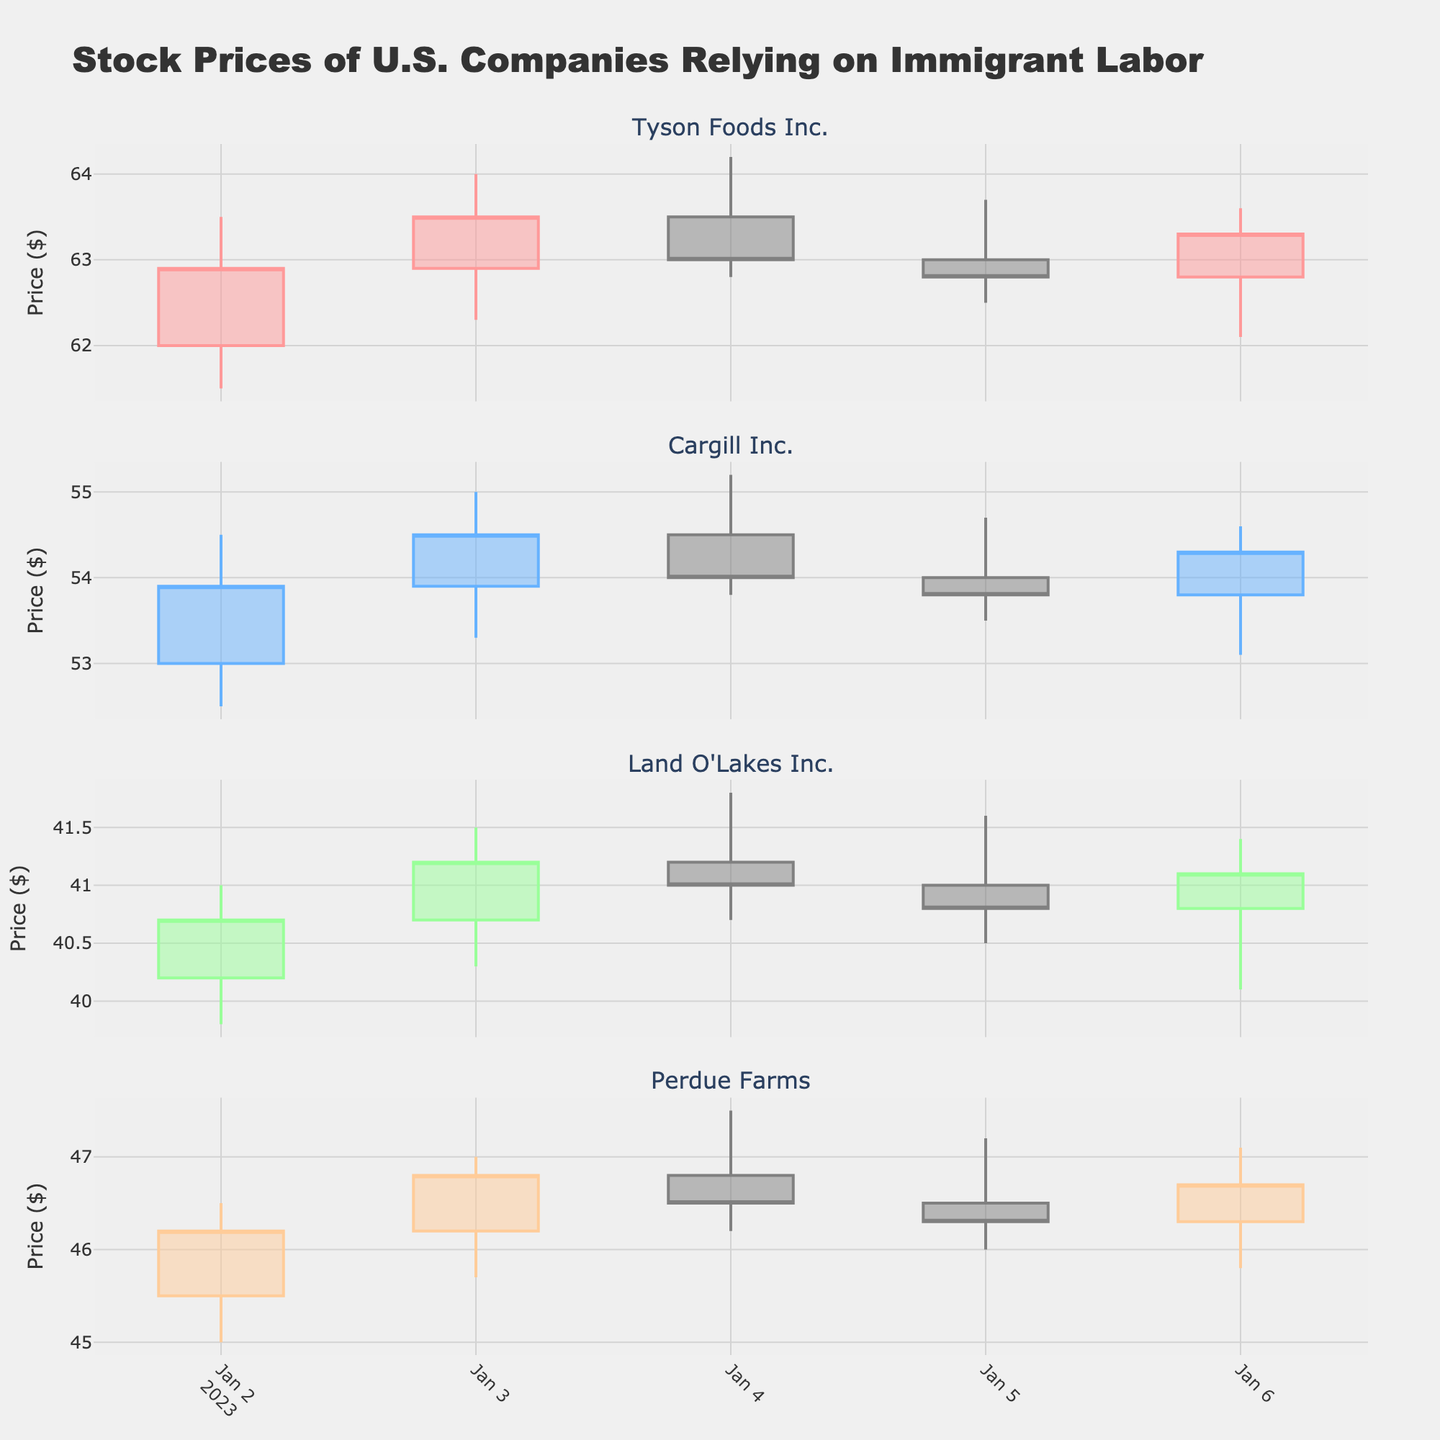What is the title of the figure? The title is usually located at the top of the figure in a larger and bolder font. It provides a concise description of what the figure represents.
Answer: Stock Prices of U.S. Companies Relying on Immigrant Labor How many companies are displayed in the figure? By counting the number of subplots, each corresponding to a different company, you can determine how many companies are represented.
Answer: Four What is the color of the increasing line for Tyson Foods Inc.? Each company has a unique color for its increasing line, and by looking at the specific company's candlestick plot, the color can be identified.
Answer: #FF9999 (light red) What was the closing price of Land O'Lakes Inc. on January 4th? Find the candlestick for January 4th in the Land O'Lakes subplot and note the position of the top of the body of the candlestick, which indicates the closing price.
Answer: 41.00 Which company had the highest closing price on January 3rd? Look at the closing prices for each company on January 3rd. The highest closing price can be found by comparing these values.
Answer: Tyson Foods Inc Calculate the average closing price for Cargill Inc. from January 2nd to January 6th. Sum the closing prices for all days within the given period and divide by the number of days to find the average. (53.90 + 54.50 + 54.00 + 53.80 + 54.30) / 5 = 270.5 / 5
Answer: 54.10 Which day had the highest trading volume for Perdue Farms? Examine the trading volume values for Perdue Farms on each day. The day with the highest volume can be identified by finding the maximum value.
Answer: January 3rd Compare the overall trend for Tyson Foods Inc. and Perdue Farms from January 2nd to January 6th. Were both companies' stock prices generally increasing, decreasing, or mixed? Analyze the candlestick patterns for each company over the given period to determine whether they show an upward, downward, or mixed trend. Tyson Foods Inc. shows minor fluctuations but ends higher than it started, whereas Perdue Farms also shows small fluctuations with an overall ending price slightly higher than the start.
Answer: Mixed What was the range (difference between High and Low) for Tyson Foods Inc. on January 5th? Subtract the Low value from the High value of Tyson Foods Inc. on January 5th to calculate the range. 63.70 - 62.50 = 1.20
Answer: 1.20 How did the closing price of Cargill Inc. on January 6th compare to its closing price on January 2nd? Compare the closing prices for the two dates to determine if the price increased, decreased, or stayed the same. 54.30 (Jan 6) compared to 53.90 (Jan 2) shows an increase.
Answer: Increased 